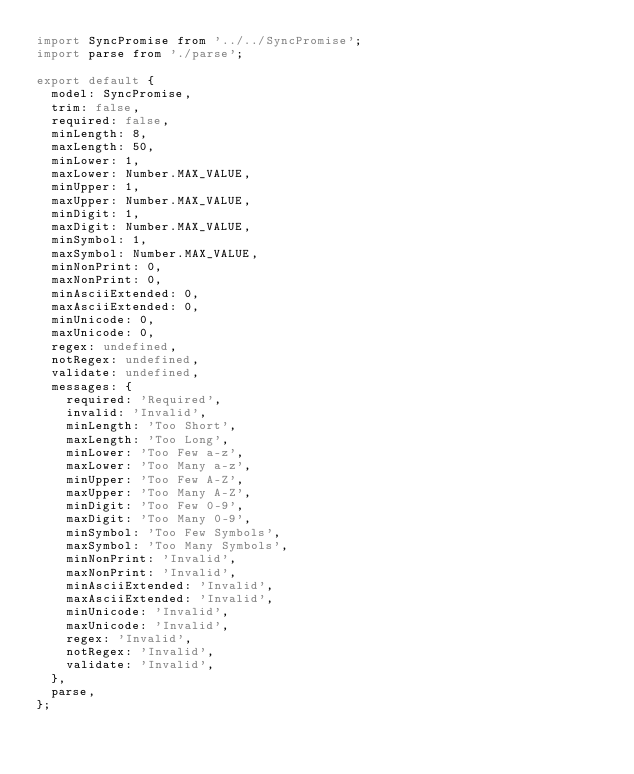Convert code to text. <code><loc_0><loc_0><loc_500><loc_500><_JavaScript_>import SyncPromise from '../../SyncPromise';
import parse from './parse';

export default {
  model: SyncPromise,
  trim: false,
  required: false,
  minLength: 8,
  maxLength: 50,
  minLower: 1,
  maxLower: Number.MAX_VALUE,
  minUpper: 1,
  maxUpper: Number.MAX_VALUE,
  minDigit: 1,
  maxDigit: Number.MAX_VALUE,
  minSymbol: 1,
  maxSymbol: Number.MAX_VALUE,
  minNonPrint: 0,
  maxNonPrint: 0,
  minAsciiExtended: 0,
  maxAsciiExtended: 0,
  minUnicode: 0,
  maxUnicode: 0,
  regex: undefined,
  notRegex: undefined,
  validate: undefined,
  messages: {
    required: 'Required',
    invalid: 'Invalid',
    minLength: 'Too Short',
    maxLength: 'Too Long',
    minLower: 'Too Few a-z',
    maxLower: 'Too Many a-z',
    minUpper: 'Too Few A-Z',
    maxUpper: 'Too Many A-Z',
    minDigit: 'Too Few 0-9',
    maxDigit: 'Too Many 0-9',
    minSymbol: 'Too Few Symbols',
    maxSymbol: 'Too Many Symbols',
    minNonPrint: 'Invalid',
    maxNonPrint: 'Invalid',
    minAsciiExtended: 'Invalid',
    maxAsciiExtended: 'Invalid',
    minUnicode: 'Invalid',
    maxUnicode: 'Invalid',
    regex: 'Invalid',
    notRegex: 'Invalid',
    validate: 'Invalid',
  },
  parse,
};
</code> 